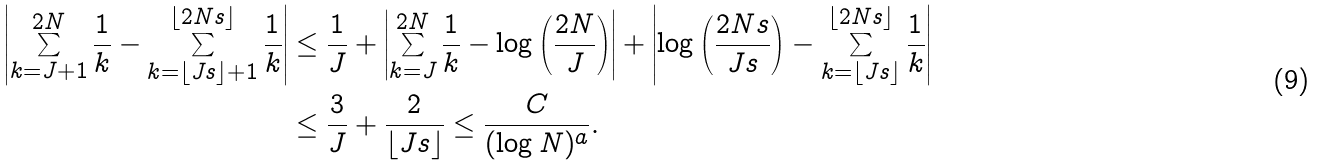<formula> <loc_0><loc_0><loc_500><loc_500>\left | \sum _ { k = J + 1 } ^ { 2 N } \frac { 1 } { k } - \sum _ { k = \lfloor J s \rfloor + 1 } ^ { \lfloor 2 N s \rfloor } \frac { 1 } { k } \right | & \leq \frac { 1 } { J } + \left | \sum _ { k = J } ^ { 2 N } \frac { 1 } { k } - \log \left ( \frac { 2 N } { J } \right ) \right | + \left | \log \left ( \frac { 2 N s } { J s } \right ) - \sum _ { k = \lfloor J s \rfloor } ^ { \lfloor 2 N s \rfloor } \frac { 1 } { k } \right | \\ & \leq \frac { 3 } { J } + \frac { 2 } { \lfloor J s \rfloor } \leq \frac { C } { ( \log N ) ^ { a } } .</formula> 